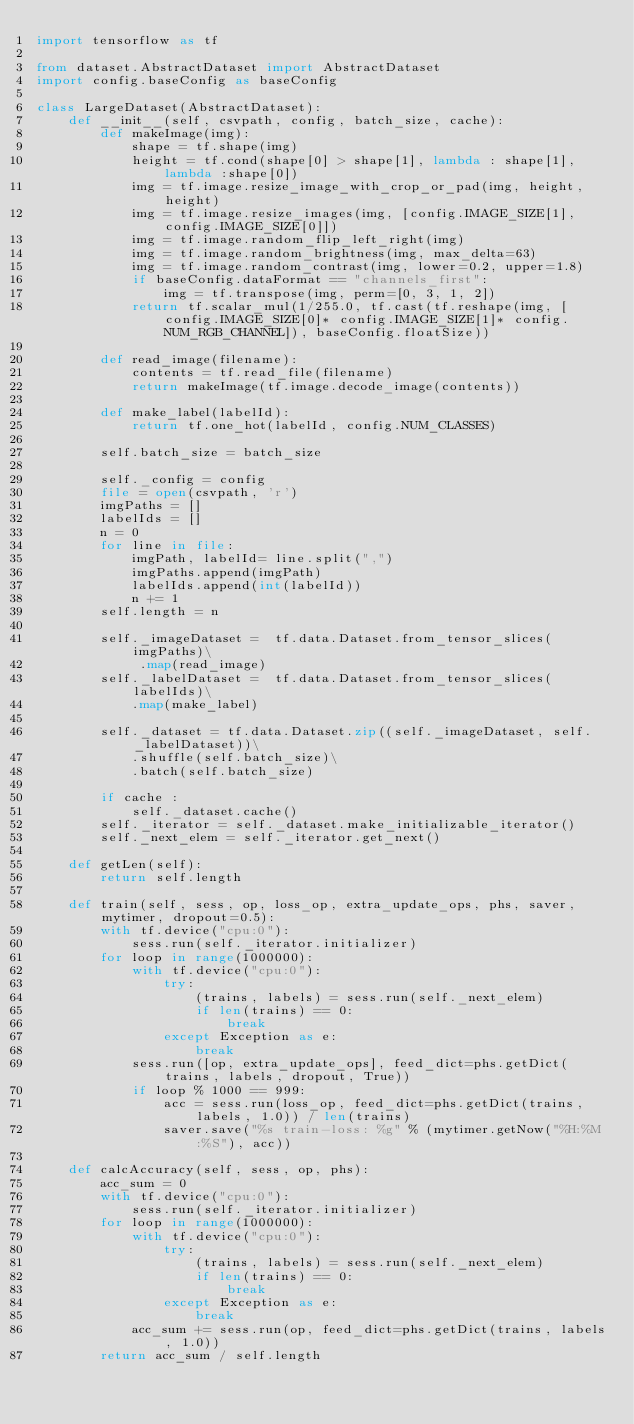Convert code to text. <code><loc_0><loc_0><loc_500><loc_500><_Python_>import tensorflow as tf

from dataset.AbstractDataset import AbstractDataset
import config.baseConfig as baseConfig

class LargeDataset(AbstractDataset):
    def __init__(self, csvpath, config, batch_size, cache):
        def makeImage(img):
            shape = tf.shape(img)
            height = tf.cond(shape[0] > shape[1], lambda : shape[1], lambda :shape[0])
            img = tf.image.resize_image_with_crop_or_pad(img, height, height)
            img = tf.image.resize_images(img, [config.IMAGE_SIZE[1],config.IMAGE_SIZE[0]])
            img = tf.image.random_flip_left_right(img)
            img = tf.image.random_brightness(img, max_delta=63)
            img = tf.image.random_contrast(img, lower=0.2, upper=1.8)
            if baseConfig.dataFormat == "channels_first":
                img = tf.transpose(img, perm=[0, 3, 1, 2])
            return tf.scalar_mul(1/255.0, tf.cast(tf.reshape(img, [config.IMAGE_SIZE[0]* config.IMAGE_SIZE[1]* config.NUM_RGB_CHANNEL]), baseConfig.floatSize))

        def read_image(filename):
            contents = tf.read_file(filename)
            return makeImage(tf.image.decode_image(contents))

        def make_label(labelId):
            return tf.one_hot(labelId, config.NUM_CLASSES)

        self.batch_size = batch_size

        self._config = config
        file = open(csvpath, 'r')
        imgPaths = []
        labelIds = []
        n = 0
        for line in file:
            imgPath, labelId= line.split(",")
            imgPaths.append(imgPath)
            labelIds.append(int(labelId))
            n += 1
        self.length = n
        
        self._imageDataset =  tf.data.Dataset.from_tensor_slices(imgPaths)\
             .map(read_image)
        self._labelDataset =  tf.data.Dataset.from_tensor_slices(labelIds)\
            .map(make_label)
        
        self._dataset = tf.data.Dataset.zip((self._imageDataset, self._labelDataset))\
            .shuffle(self.batch_size)\
            .batch(self.batch_size)
        
        if cache :
            self._dataset.cache()
        self._iterator = self._dataset.make_initializable_iterator()
        self._next_elem = self._iterator.get_next()

    def getLen(self):
        return self.length

    def train(self, sess, op, loss_op, extra_update_ops, phs, saver, mytimer, dropout=0.5):
        with tf.device("cpu:0"):
            sess.run(self._iterator.initializer)
        for loop in range(1000000):
            with tf.device("cpu:0"):
                try:
                    (trains, labels) = sess.run(self._next_elem)
                    if len(trains) == 0:
                        break
                except Exception as e:
                    break
            sess.run([op, extra_update_ops], feed_dict=phs.getDict(trains, labels, dropout, True))
            if loop % 1000 == 999:
                acc = sess.run(loss_op, feed_dict=phs.getDict(trains, labels, 1.0)) / len(trains)
                saver.save("%s train-loss: %g" % (mytimer.getNow("%H:%M:%S"), acc))
  
    def calcAccuracy(self, sess, op, phs):
        acc_sum = 0
        with tf.device("cpu:0"):
            sess.run(self._iterator.initializer)
        for loop in range(1000000):
            with tf.device("cpu:0"):
                try:
                    (trains, labels) = sess.run(self._next_elem)
                    if len(trains) == 0:
                        break
                except Exception as e:
                    break
            acc_sum += sess.run(op, feed_dict=phs.getDict(trains, labels, 1.0))
        return acc_sum / self.length
</code> 